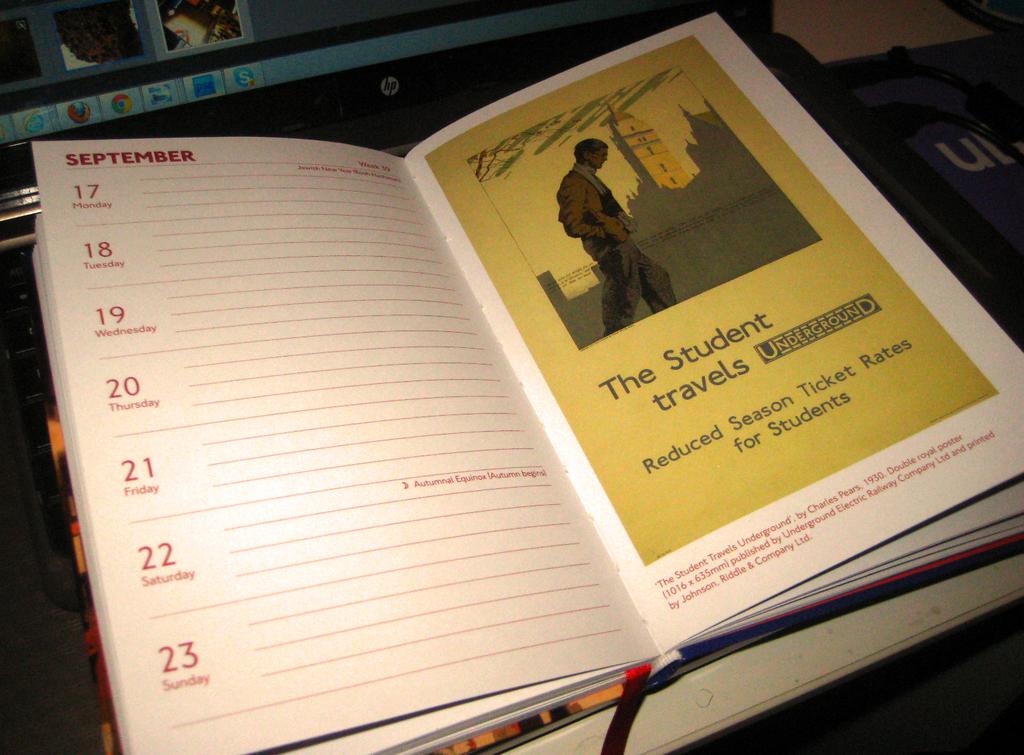What is this planner for?
Give a very brief answer. Students. What month is the planner opened to?
Provide a succinct answer. September. 